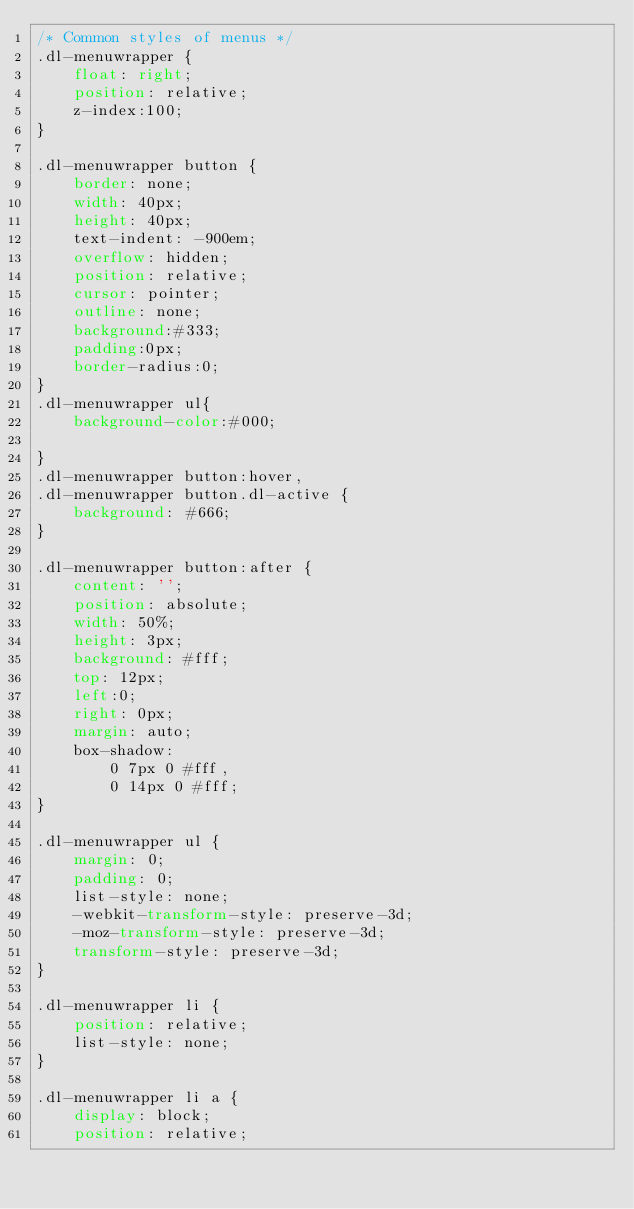<code> <loc_0><loc_0><loc_500><loc_500><_CSS_>/* Common styles of menus */
.dl-menuwrapper {
	float: right;
	position: relative;
	z-index:100;
}

.dl-menuwrapper button {
	border: none;
	width: 40px;
	height: 40px;
	text-indent: -900em;
	overflow: hidden;
	position: relative;
	cursor: pointer;
	outline: none;
	background:#333;
	padding:0px;
	border-radius:0;
}
.dl-menuwrapper ul{
	background-color:#000;

}
.dl-menuwrapper button:hover,
.dl-menuwrapper button.dl-active {
	background: #666;
}

.dl-menuwrapper button:after {
	content: '';
	position: absolute;
	width: 50%;
	height: 3px;
	background: #fff;
	top: 12px;
	left:0;
	right: 0px;
	margin: auto;
	box-shadow: 
		0 7px 0 #fff, 
		0 14px 0 #fff;
}

.dl-menuwrapper ul {
	margin: 0;
	padding: 0;
	list-style: none;
	-webkit-transform-style: preserve-3d;
	-moz-transform-style: preserve-3d;
	transform-style: preserve-3d;
}

.dl-menuwrapper li {
	position: relative;
	list-style: none;
}

.dl-menuwrapper li a {
	display: block;
	position: relative;</code> 